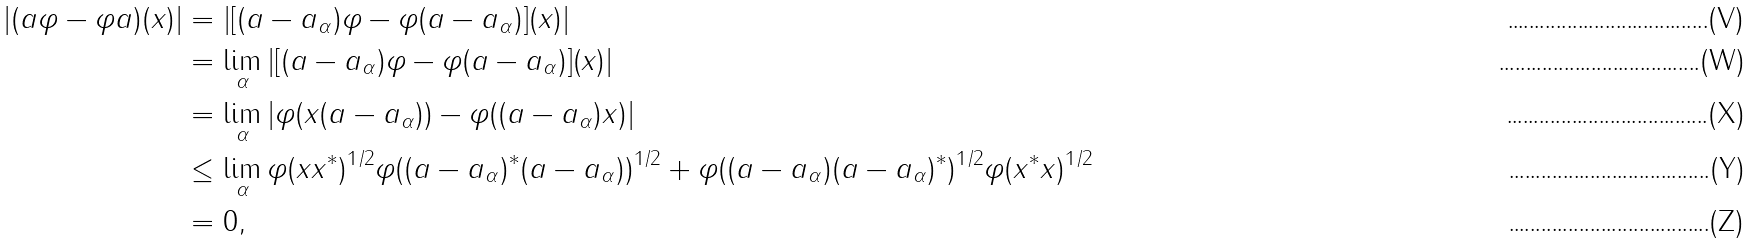Convert formula to latex. <formula><loc_0><loc_0><loc_500><loc_500>| ( a \varphi - \varphi a ) ( x ) | & = | [ ( a - a _ { \alpha } ) \varphi - \varphi ( a - a _ { \alpha } ) ] ( x ) | \\ & = \lim _ { \alpha } | [ ( a - a _ { \alpha } ) \varphi - \varphi ( a - a _ { \alpha } ) ] ( x ) | \\ & = \lim _ { \alpha } | \varphi ( x ( a - a _ { \alpha } ) ) - \varphi ( ( a - a _ { \alpha } ) x ) | \\ & \leq \lim _ { \alpha } \varphi ( x x ^ { * } ) ^ { 1 / 2 } \varphi ( ( a - a _ { \alpha } ) ^ { * } ( a - a _ { \alpha } ) ) ^ { 1 / 2 } + \varphi ( ( a - a _ { \alpha } ) ( a - a _ { \alpha } ) ^ { * } ) ^ { 1 / 2 } \varphi ( x ^ { * } x ) ^ { 1 / 2 } \\ & = 0 ,</formula> 